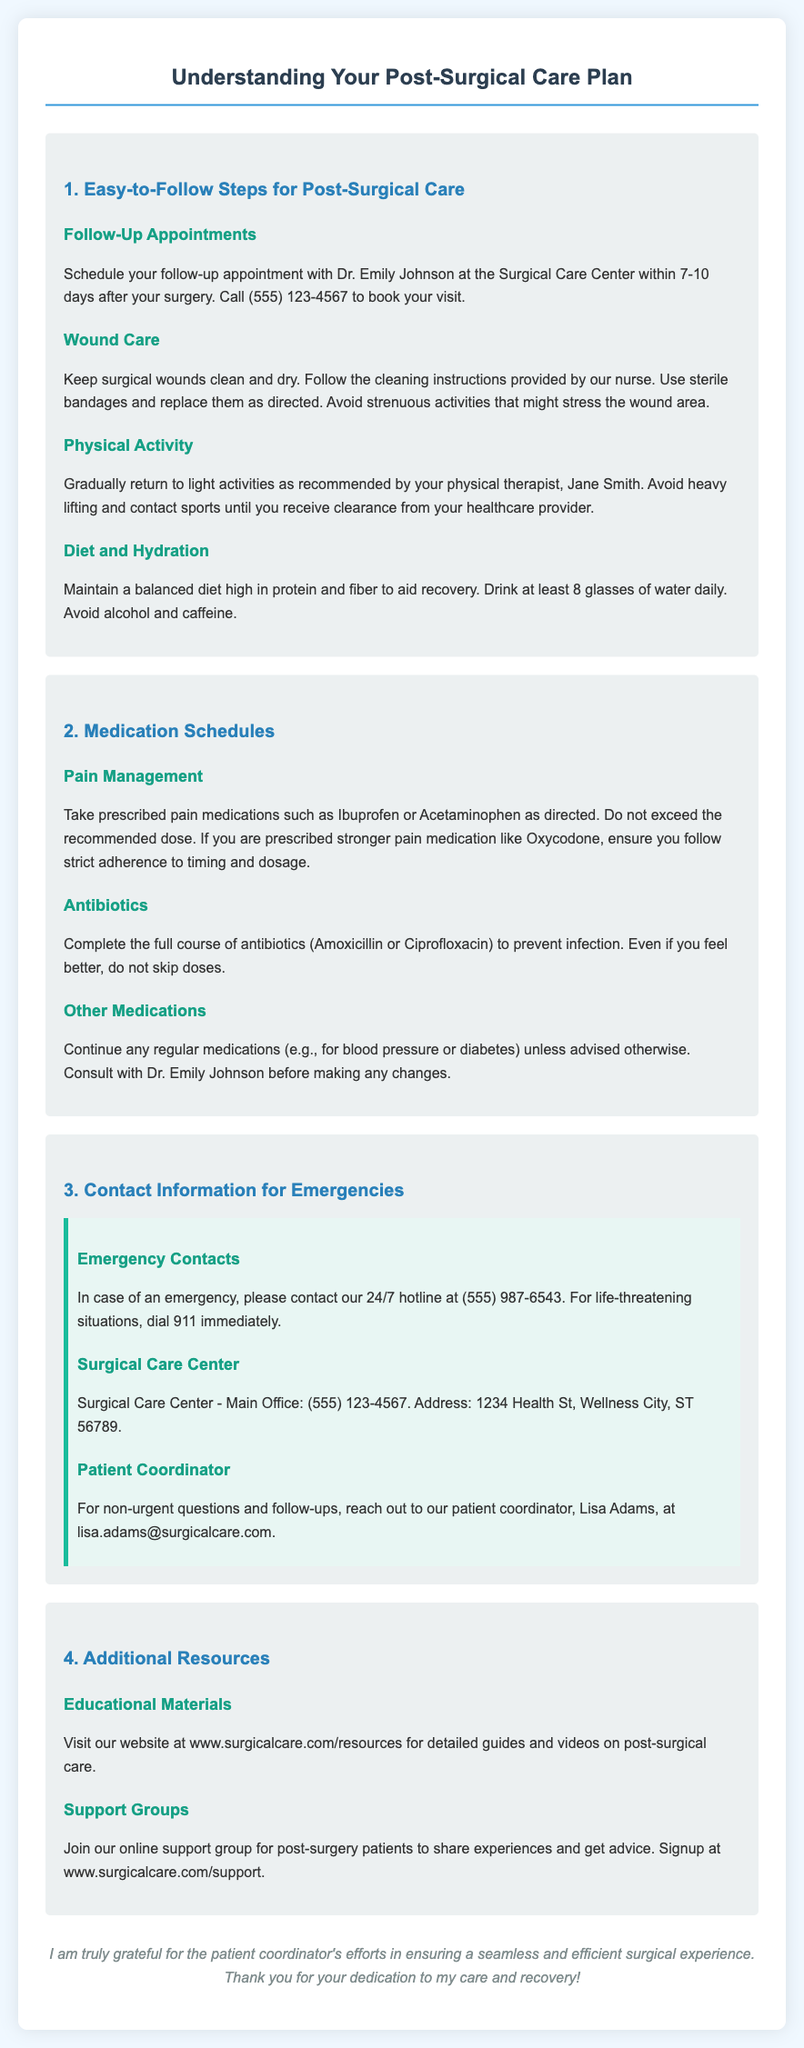What is the name of the doctor for follow-up appointments? The document specifies Dr. Emily Johnson for follow-up appointments at the Surgical Care Center.
Answer: Dr. Emily Johnson What is the contact number for scheduling a follow-up appointment? The contact number provided for booking a follow-up appointment is mentioned in the document.
Answer: (555) 123-4567 How many glasses of water should be drunk daily? The document indicates that at least 8 glasses of water should be consumed daily for hydration.
Answer: 8 What medications should be completed to prevent infection? The document lists Amoxicillin or Ciprofloxacin as medications that should be completed to prevent infection.
Answer: Amoxicillin or Ciprofloxacin What is the address of the Surgical Care Center? The address for the Surgical Care Center is provided in the document.
Answer: 1234 Health St, Wellness City, ST 56789 What should you avoid until cleared by a healthcare provider? The document advises avoiding heavy lifting and contact sports until receiving clearance from a healthcare provider.
Answer: Heavy lifting and contact sports What type of resources can be found on the website mentioned? The document points to educational materials available at the website for post-surgical care.
Answer: Educational materials Who should be contacted for non-urgent questions? The document states that Lisa Adams is the patient coordinator to contact for non-urgent questions.
Answer: Lisa Adams How long after surgery should follow-up appointments be scheduled? The document specifies that follow-up appointments should be scheduled within 7-10 days after surgery.
Answer: 7-10 days 